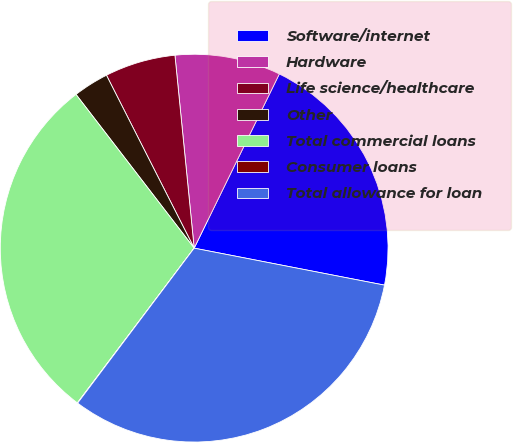<chart> <loc_0><loc_0><loc_500><loc_500><pie_chart><fcel>Software/internet<fcel>Hardware<fcel>Life science/healthcare<fcel>Other<fcel>Total commercial loans<fcel>Consumer loans<fcel>Total allowance for loan<nl><fcel>20.82%<fcel>8.82%<fcel>5.89%<fcel>2.96%<fcel>29.28%<fcel>0.03%<fcel>32.21%<nl></chart> 